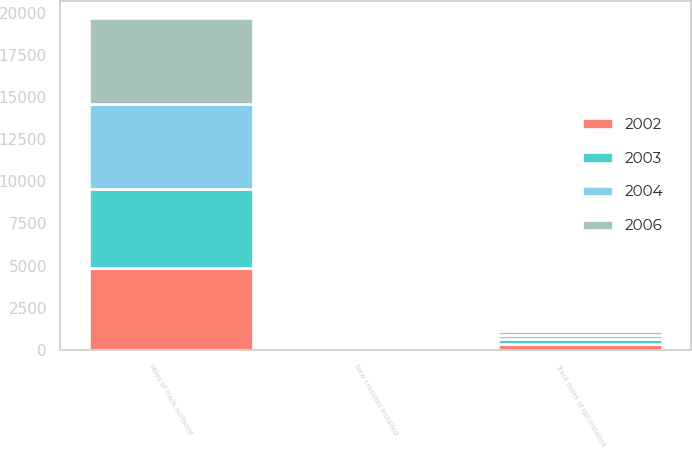<chart> <loc_0><loc_0><loc_500><loc_500><stacked_bar_chart><ecel><fcel>Track miles of rail installed<fcel>Miles of track surfaced<fcel>New crossties installed<nl><fcel>2002<fcel>327<fcel>4871<fcel>2.7<nl><fcel>2003<fcel>302<fcel>4663<fcel>2.5<nl><fcel>2004<fcel>246<fcel>5055<fcel>2.5<nl><fcel>2006<fcel>233<fcel>5105<fcel>2.8<nl></chart> 